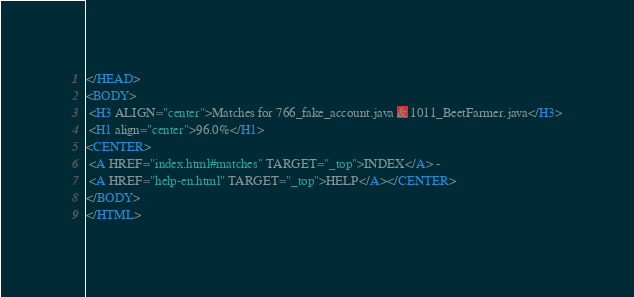Convert code to text. <code><loc_0><loc_0><loc_500><loc_500><_HTML_></HEAD>
<BODY>
 <H3 ALIGN="center">Matches for 766_fake_account.java & 1011_BeetFarmer.java</H3>
 <H1 align="center">96.0%</H1>
<CENTER>
 <A HREF="index.html#matches" TARGET="_top">INDEX</A> - 
 <A HREF="help-en.html" TARGET="_top">HELP</A></CENTER>
</BODY>
</HTML>
</code> 